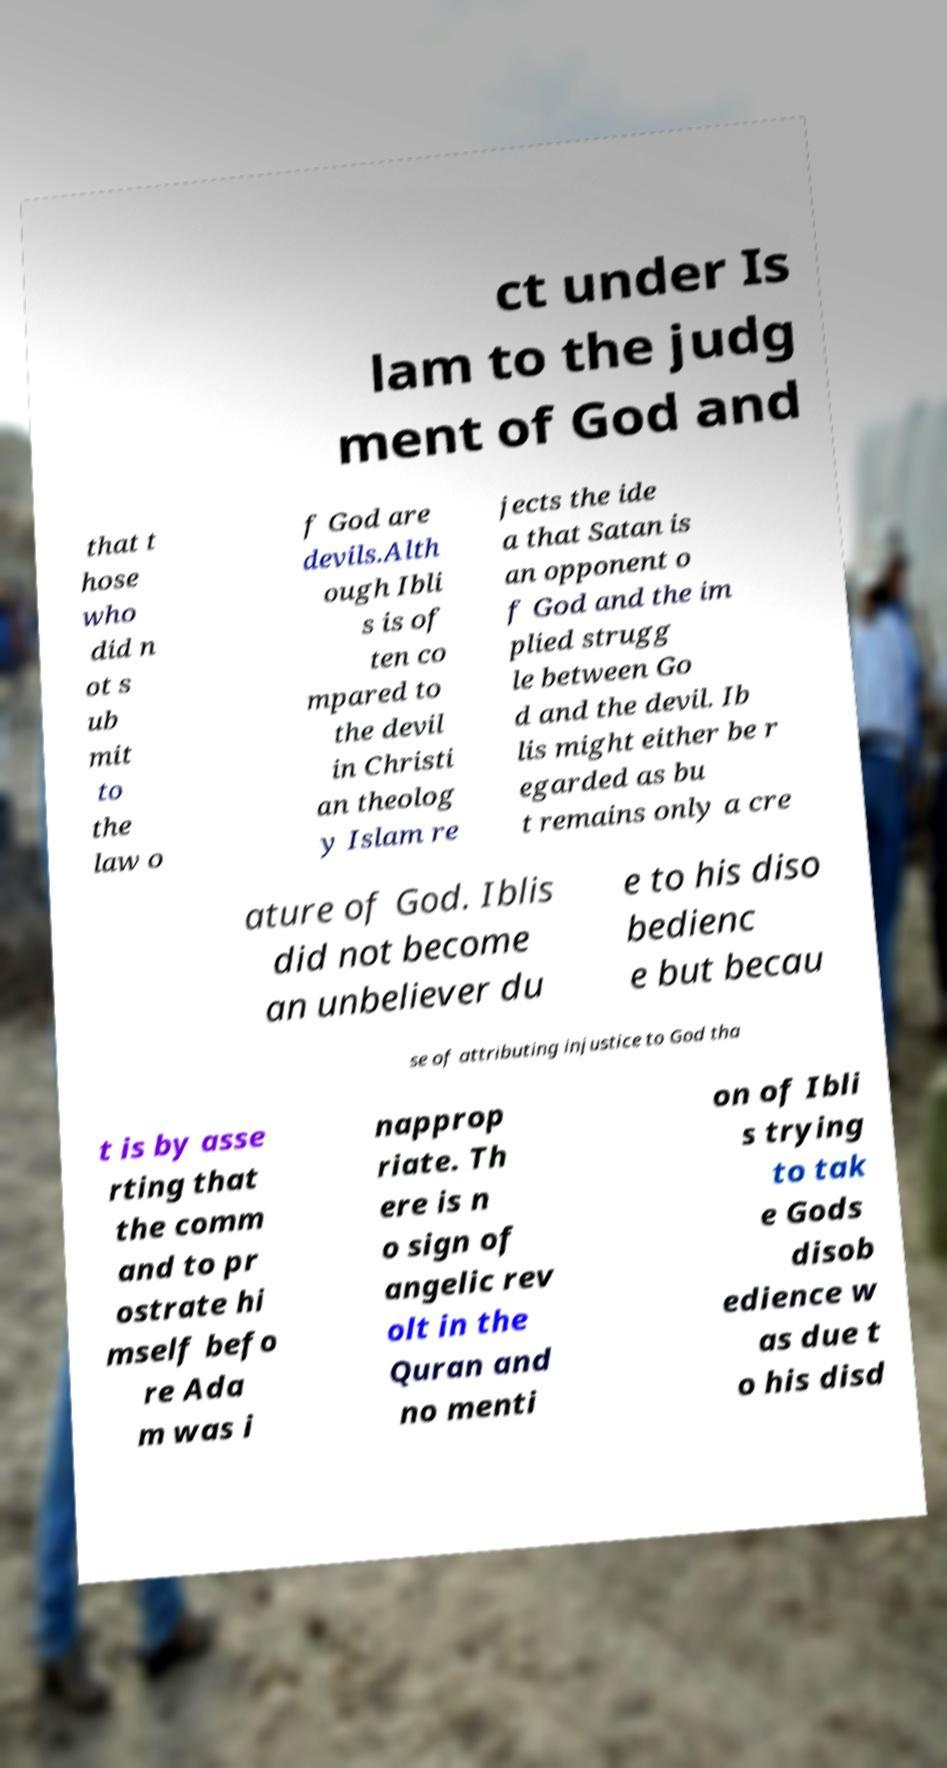Could you extract and type out the text from this image? ct under Is lam to the judg ment of God and that t hose who did n ot s ub mit to the law o f God are devils.Alth ough Ibli s is of ten co mpared to the devil in Christi an theolog y Islam re jects the ide a that Satan is an opponent o f God and the im plied strugg le between Go d and the devil. Ib lis might either be r egarded as bu t remains only a cre ature of God. Iblis did not become an unbeliever du e to his diso bedienc e but becau se of attributing injustice to God tha t is by asse rting that the comm and to pr ostrate hi mself befo re Ada m was i napprop riate. Th ere is n o sign of angelic rev olt in the Quran and no menti on of Ibli s trying to tak e Gods disob edience w as due t o his disd 